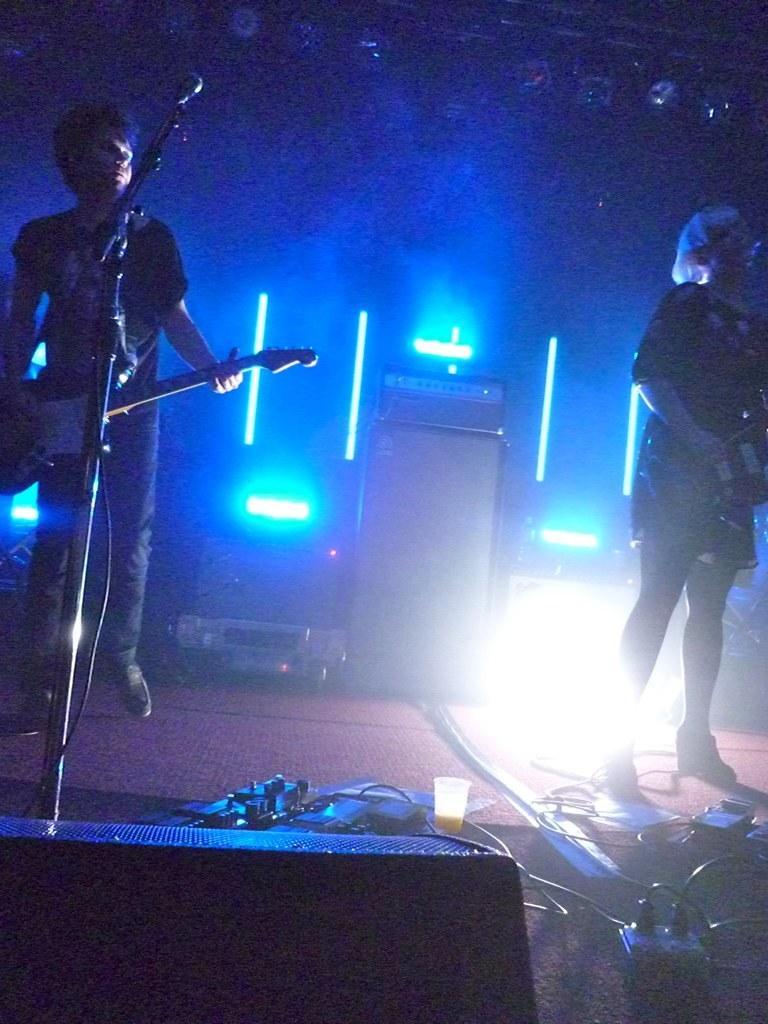Can you describe this image briefly? In the image there are two people man and a woman. Who are holding there are musical instrument and standing in front of a microphone to play music with it, in background we can see speakers,lights at bottom there is a switch board, wires and a glass. 